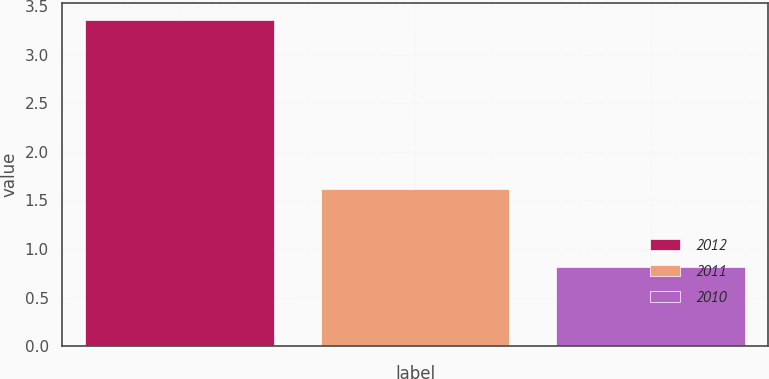Convert chart. <chart><loc_0><loc_0><loc_500><loc_500><bar_chart><fcel>2012<fcel>2011<fcel>2010<nl><fcel>3.36<fcel>1.62<fcel>0.81<nl></chart> 